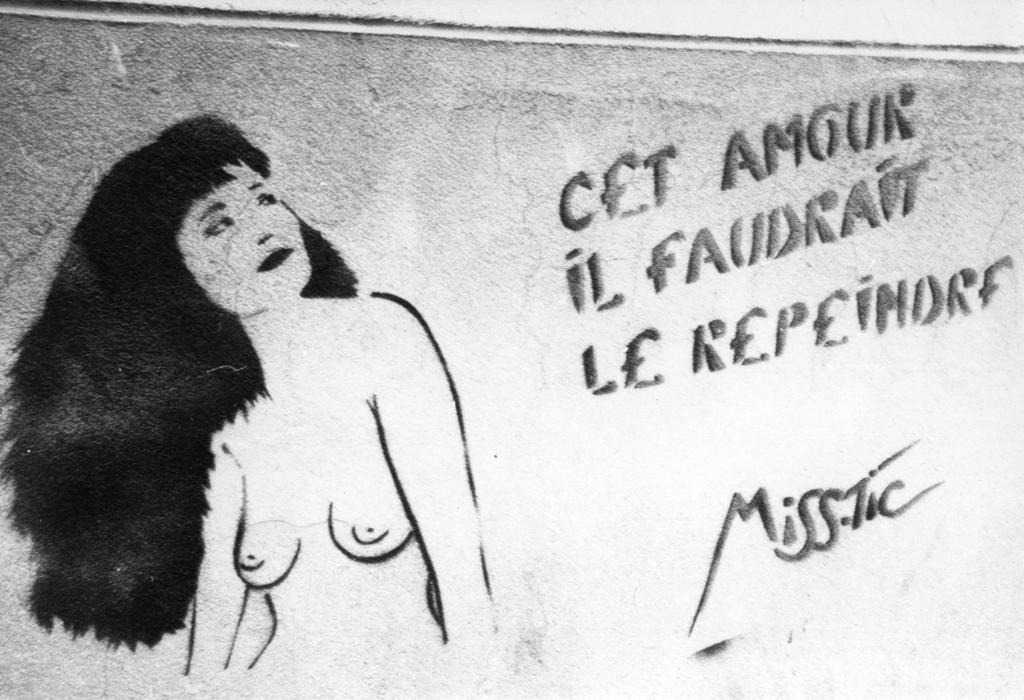What is the color scheme of the image? The image is black and white. What can be seen in the image besides the color scheme? There is a poster in the image. What is depicted on the poster? The poster features a woman. Are there any words or phrases on the poster? Yes, text is written on the poster. Can you hear any music playing in the image? There is no audio or sound present in the image, so it is not possible to hear any music. 